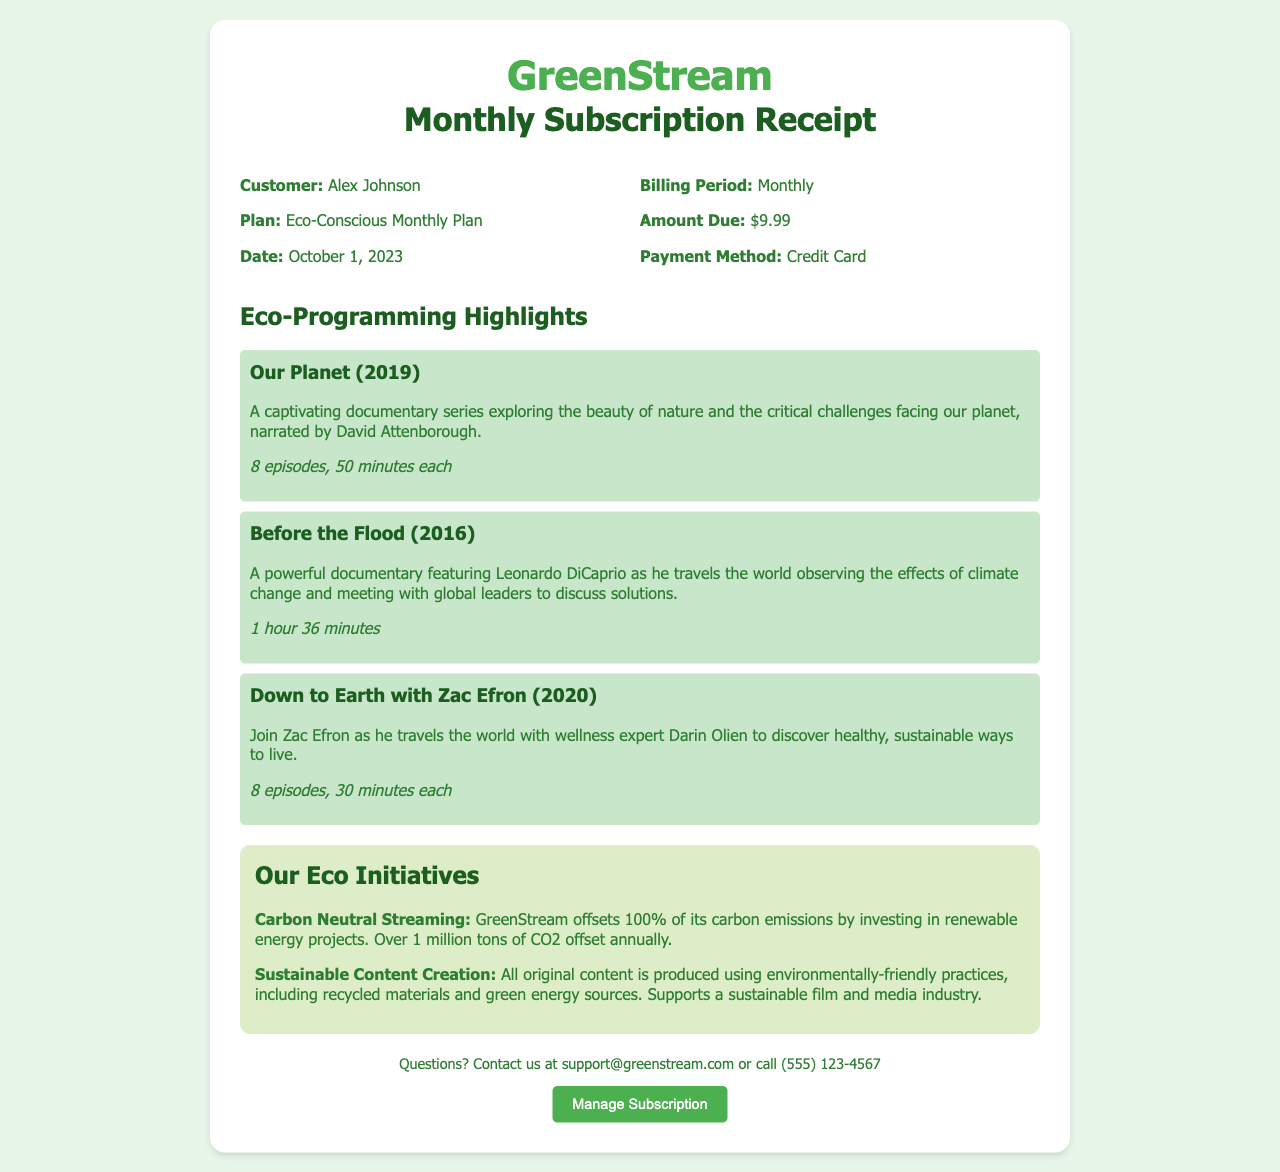What is the customer's name? The receipt lists the customer as Alex Johnson.
Answer: Alex Johnson What is the date of the receipt? The date mentioned in the receipt is October 1, 2023.
Answer: October 1, 2023 How much is the monthly subscription fee? The amount due for the subscription is stated as $9.99.
Answer: $9.99 What documentary features David Attenborough? The highlighted documentary exploring nature narrated by David Attenborough is titled "Our Planet."
Answer: Our Planet How many episodes are in "Down to Earth with Zac Efron"? The document mentions that "Down to Earth with Zac Efron" has 8 episodes.
Answer: 8 episodes What eco initiative offsets 1 million tons of CO2? The receipt mentions that GreenStream offsets carbon emissions through Carbon Neutral Streaming.
Answer: Carbon Neutral Streaming What is the phone contact for inquiries? The contact number provided for questions is (555) 123-4567.
Answer: (555) 123-4567 What is the payment method used for the subscription? The payment method listed in the receipt is Credit Card.
Answer: Credit Card How long is the documentary "Before the Flood"? The length of "Before the Flood" is mentioned as 1 hour 36 minutes.
Answer: 1 hour 36 minutes 